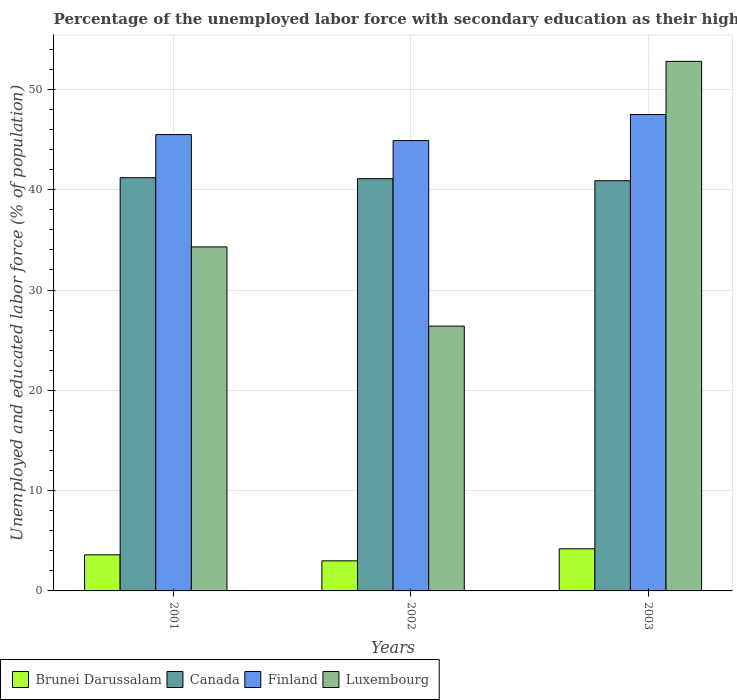How many different coloured bars are there?
Offer a very short reply. 4. Are the number of bars per tick equal to the number of legend labels?
Offer a terse response. Yes. How many bars are there on the 3rd tick from the left?
Keep it short and to the point. 4. How many bars are there on the 3rd tick from the right?
Make the answer very short. 4. In how many cases, is the number of bars for a given year not equal to the number of legend labels?
Your answer should be very brief. 0. What is the percentage of the unemployed labor force with secondary education in Canada in 2001?
Your answer should be compact. 41.2. Across all years, what is the maximum percentage of the unemployed labor force with secondary education in Canada?
Offer a terse response. 41.2. Across all years, what is the minimum percentage of the unemployed labor force with secondary education in Luxembourg?
Give a very brief answer. 26.4. In which year was the percentage of the unemployed labor force with secondary education in Canada maximum?
Ensure brevity in your answer.  2001. What is the total percentage of the unemployed labor force with secondary education in Finland in the graph?
Ensure brevity in your answer.  137.9. What is the difference between the percentage of the unemployed labor force with secondary education in Brunei Darussalam in 2001 and that in 2003?
Ensure brevity in your answer.  -0.6. What is the difference between the percentage of the unemployed labor force with secondary education in Finland in 2001 and the percentage of the unemployed labor force with secondary education in Luxembourg in 2002?
Your answer should be very brief. 19.1. What is the average percentage of the unemployed labor force with secondary education in Finland per year?
Make the answer very short. 45.97. In the year 2001, what is the difference between the percentage of the unemployed labor force with secondary education in Luxembourg and percentage of the unemployed labor force with secondary education in Brunei Darussalam?
Offer a terse response. 30.7. In how many years, is the percentage of the unemployed labor force with secondary education in Brunei Darussalam greater than 52 %?
Your answer should be very brief. 0. What is the ratio of the percentage of the unemployed labor force with secondary education in Brunei Darussalam in 2001 to that in 2003?
Your response must be concise. 0.86. What is the difference between the highest and the second highest percentage of the unemployed labor force with secondary education in Finland?
Provide a short and direct response. 2. What is the difference between the highest and the lowest percentage of the unemployed labor force with secondary education in Canada?
Your response must be concise. 0.3. In how many years, is the percentage of the unemployed labor force with secondary education in Canada greater than the average percentage of the unemployed labor force with secondary education in Canada taken over all years?
Offer a terse response. 2. What does the 4th bar from the left in 2001 represents?
Keep it short and to the point. Luxembourg. What does the 2nd bar from the right in 2003 represents?
Provide a short and direct response. Finland. Is it the case that in every year, the sum of the percentage of the unemployed labor force with secondary education in Brunei Darussalam and percentage of the unemployed labor force with secondary education in Luxembourg is greater than the percentage of the unemployed labor force with secondary education in Canada?
Offer a very short reply. No. How many bars are there?
Offer a terse response. 12. How many years are there in the graph?
Offer a terse response. 3. What is the difference between two consecutive major ticks on the Y-axis?
Your answer should be compact. 10. Are the values on the major ticks of Y-axis written in scientific E-notation?
Ensure brevity in your answer.  No. Does the graph contain grids?
Offer a very short reply. Yes. Where does the legend appear in the graph?
Provide a succinct answer. Bottom left. How many legend labels are there?
Offer a very short reply. 4. How are the legend labels stacked?
Offer a terse response. Horizontal. What is the title of the graph?
Offer a terse response. Percentage of the unemployed labor force with secondary education as their highest grade. Does "Libya" appear as one of the legend labels in the graph?
Provide a short and direct response. No. What is the label or title of the Y-axis?
Provide a succinct answer. Unemployed and educated labor force (% of population). What is the Unemployed and educated labor force (% of population) in Brunei Darussalam in 2001?
Your answer should be compact. 3.6. What is the Unemployed and educated labor force (% of population) in Canada in 2001?
Provide a short and direct response. 41.2. What is the Unemployed and educated labor force (% of population) of Finland in 2001?
Offer a terse response. 45.5. What is the Unemployed and educated labor force (% of population) of Luxembourg in 2001?
Offer a terse response. 34.3. What is the Unemployed and educated labor force (% of population) of Canada in 2002?
Your answer should be compact. 41.1. What is the Unemployed and educated labor force (% of population) of Finland in 2002?
Offer a terse response. 44.9. What is the Unemployed and educated labor force (% of population) in Luxembourg in 2002?
Ensure brevity in your answer.  26.4. What is the Unemployed and educated labor force (% of population) of Brunei Darussalam in 2003?
Provide a short and direct response. 4.2. What is the Unemployed and educated labor force (% of population) in Canada in 2003?
Make the answer very short. 40.9. What is the Unemployed and educated labor force (% of population) in Finland in 2003?
Offer a terse response. 47.5. What is the Unemployed and educated labor force (% of population) of Luxembourg in 2003?
Provide a succinct answer. 52.8. Across all years, what is the maximum Unemployed and educated labor force (% of population) in Brunei Darussalam?
Offer a very short reply. 4.2. Across all years, what is the maximum Unemployed and educated labor force (% of population) of Canada?
Make the answer very short. 41.2. Across all years, what is the maximum Unemployed and educated labor force (% of population) of Finland?
Your answer should be compact. 47.5. Across all years, what is the maximum Unemployed and educated labor force (% of population) in Luxembourg?
Offer a very short reply. 52.8. Across all years, what is the minimum Unemployed and educated labor force (% of population) of Brunei Darussalam?
Provide a succinct answer. 3. Across all years, what is the minimum Unemployed and educated labor force (% of population) in Canada?
Provide a short and direct response. 40.9. Across all years, what is the minimum Unemployed and educated labor force (% of population) in Finland?
Ensure brevity in your answer.  44.9. Across all years, what is the minimum Unemployed and educated labor force (% of population) in Luxembourg?
Ensure brevity in your answer.  26.4. What is the total Unemployed and educated labor force (% of population) of Canada in the graph?
Ensure brevity in your answer.  123.2. What is the total Unemployed and educated labor force (% of population) in Finland in the graph?
Provide a succinct answer. 137.9. What is the total Unemployed and educated labor force (% of population) of Luxembourg in the graph?
Offer a terse response. 113.5. What is the difference between the Unemployed and educated labor force (% of population) of Brunei Darussalam in 2001 and that in 2002?
Offer a terse response. 0.6. What is the difference between the Unemployed and educated labor force (% of population) of Finland in 2001 and that in 2003?
Ensure brevity in your answer.  -2. What is the difference between the Unemployed and educated labor force (% of population) in Luxembourg in 2001 and that in 2003?
Your response must be concise. -18.5. What is the difference between the Unemployed and educated labor force (% of population) of Finland in 2002 and that in 2003?
Ensure brevity in your answer.  -2.6. What is the difference between the Unemployed and educated labor force (% of population) of Luxembourg in 2002 and that in 2003?
Your response must be concise. -26.4. What is the difference between the Unemployed and educated labor force (% of population) in Brunei Darussalam in 2001 and the Unemployed and educated labor force (% of population) in Canada in 2002?
Offer a terse response. -37.5. What is the difference between the Unemployed and educated labor force (% of population) of Brunei Darussalam in 2001 and the Unemployed and educated labor force (% of population) of Finland in 2002?
Provide a succinct answer. -41.3. What is the difference between the Unemployed and educated labor force (% of population) of Brunei Darussalam in 2001 and the Unemployed and educated labor force (% of population) of Luxembourg in 2002?
Provide a succinct answer. -22.8. What is the difference between the Unemployed and educated labor force (% of population) of Canada in 2001 and the Unemployed and educated labor force (% of population) of Luxembourg in 2002?
Offer a terse response. 14.8. What is the difference between the Unemployed and educated labor force (% of population) in Finland in 2001 and the Unemployed and educated labor force (% of population) in Luxembourg in 2002?
Provide a succinct answer. 19.1. What is the difference between the Unemployed and educated labor force (% of population) of Brunei Darussalam in 2001 and the Unemployed and educated labor force (% of population) of Canada in 2003?
Make the answer very short. -37.3. What is the difference between the Unemployed and educated labor force (% of population) in Brunei Darussalam in 2001 and the Unemployed and educated labor force (% of population) in Finland in 2003?
Your response must be concise. -43.9. What is the difference between the Unemployed and educated labor force (% of population) of Brunei Darussalam in 2001 and the Unemployed and educated labor force (% of population) of Luxembourg in 2003?
Offer a terse response. -49.2. What is the difference between the Unemployed and educated labor force (% of population) in Canada in 2001 and the Unemployed and educated labor force (% of population) in Finland in 2003?
Provide a short and direct response. -6.3. What is the difference between the Unemployed and educated labor force (% of population) in Canada in 2001 and the Unemployed and educated labor force (% of population) in Luxembourg in 2003?
Keep it short and to the point. -11.6. What is the difference between the Unemployed and educated labor force (% of population) in Finland in 2001 and the Unemployed and educated labor force (% of population) in Luxembourg in 2003?
Give a very brief answer. -7.3. What is the difference between the Unemployed and educated labor force (% of population) in Brunei Darussalam in 2002 and the Unemployed and educated labor force (% of population) in Canada in 2003?
Keep it short and to the point. -37.9. What is the difference between the Unemployed and educated labor force (% of population) in Brunei Darussalam in 2002 and the Unemployed and educated labor force (% of population) in Finland in 2003?
Keep it short and to the point. -44.5. What is the difference between the Unemployed and educated labor force (% of population) in Brunei Darussalam in 2002 and the Unemployed and educated labor force (% of population) in Luxembourg in 2003?
Your answer should be very brief. -49.8. What is the difference between the Unemployed and educated labor force (% of population) in Finland in 2002 and the Unemployed and educated labor force (% of population) in Luxembourg in 2003?
Provide a short and direct response. -7.9. What is the average Unemployed and educated labor force (% of population) of Brunei Darussalam per year?
Your answer should be compact. 3.6. What is the average Unemployed and educated labor force (% of population) in Canada per year?
Keep it short and to the point. 41.07. What is the average Unemployed and educated labor force (% of population) in Finland per year?
Your answer should be very brief. 45.97. What is the average Unemployed and educated labor force (% of population) in Luxembourg per year?
Make the answer very short. 37.83. In the year 2001, what is the difference between the Unemployed and educated labor force (% of population) of Brunei Darussalam and Unemployed and educated labor force (% of population) of Canada?
Offer a very short reply. -37.6. In the year 2001, what is the difference between the Unemployed and educated labor force (% of population) in Brunei Darussalam and Unemployed and educated labor force (% of population) in Finland?
Make the answer very short. -41.9. In the year 2001, what is the difference between the Unemployed and educated labor force (% of population) of Brunei Darussalam and Unemployed and educated labor force (% of population) of Luxembourg?
Give a very brief answer. -30.7. In the year 2001, what is the difference between the Unemployed and educated labor force (% of population) in Canada and Unemployed and educated labor force (% of population) in Finland?
Offer a terse response. -4.3. In the year 2001, what is the difference between the Unemployed and educated labor force (% of population) of Canada and Unemployed and educated labor force (% of population) of Luxembourg?
Ensure brevity in your answer.  6.9. In the year 2001, what is the difference between the Unemployed and educated labor force (% of population) of Finland and Unemployed and educated labor force (% of population) of Luxembourg?
Your response must be concise. 11.2. In the year 2002, what is the difference between the Unemployed and educated labor force (% of population) of Brunei Darussalam and Unemployed and educated labor force (% of population) of Canada?
Your answer should be compact. -38.1. In the year 2002, what is the difference between the Unemployed and educated labor force (% of population) of Brunei Darussalam and Unemployed and educated labor force (% of population) of Finland?
Make the answer very short. -41.9. In the year 2002, what is the difference between the Unemployed and educated labor force (% of population) of Brunei Darussalam and Unemployed and educated labor force (% of population) of Luxembourg?
Your response must be concise. -23.4. In the year 2002, what is the difference between the Unemployed and educated labor force (% of population) in Canada and Unemployed and educated labor force (% of population) in Luxembourg?
Provide a succinct answer. 14.7. In the year 2002, what is the difference between the Unemployed and educated labor force (% of population) in Finland and Unemployed and educated labor force (% of population) in Luxembourg?
Provide a short and direct response. 18.5. In the year 2003, what is the difference between the Unemployed and educated labor force (% of population) in Brunei Darussalam and Unemployed and educated labor force (% of population) in Canada?
Offer a terse response. -36.7. In the year 2003, what is the difference between the Unemployed and educated labor force (% of population) of Brunei Darussalam and Unemployed and educated labor force (% of population) of Finland?
Your answer should be compact. -43.3. In the year 2003, what is the difference between the Unemployed and educated labor force (% of population) of Brunei Darussalam and Unemployed and educated labor force (% of population) of Luxembourg?
Ensure brevity in your answer.  -48.6. In the year 2003, what is the difference between the Unemployed and educated labor force (% of population) of Canada and Unemployed and educated labor force (% of population) of Luxembourg?
Provide a short and direct response. -11.9. In the year 2003, what is the difference between the Unemployed and educated labor force (% of population) in Finland and Unemployed and educated labor force (% of population) in Luxembourg?
Make the answer very short. -5.3. What is the ratio of the Unemployed and educated labor force (% of population) of Finland in 2001 to that in 2002?
Offer a very short reply. 1.01. What is the ratio of the Unemployed and educated labor force (% of population) in Luxembourg in 2001 to that in 2002?
Make the answer very short. 1.3. What is the ratio of the Unemployed and educated labor force (% of population) in Canada in 2001 to that in 2003?
Your response must be concise. 1.01. What is the ratio of the Unemployed and educated labor force (% of population) in Finland in 2001 to that in 2003?
Provide a short and direct response. 0.96. What is the ratio of the Unemployed and educated labor force (% of population) of Luxembourg in 2001 to that in 2003?
Give a very brief answer. 0.65. What is the ratio of the Unemployed and educated labor force (% of population) of Canada in 2002 to that in 2003?
Keep it short and to the point. 1. What is the ratio of the Unemployed and educated labor force (% of population) in Finland in 2002 to that in 2003?
Make the answer very short. 0.95. What is the difference between the highest and the second highest Unemployed and educated labor force (% of population) of Finland?
Make the answer very short. 2. What is the difference between the highest and the lowest Unemployed and educated labor force (% of population) of Canada?
Offer a very short reply. 0.3. What is the difference between the highest and the lowest Unemployed and educated labor force (% of population) in Finland?
Make the answer very short. 2.6. What is the difference between the highest and the lowest Unemployed and educated labor force (% of population) of Luxembourg?
Make the answer very short. 26.4. 